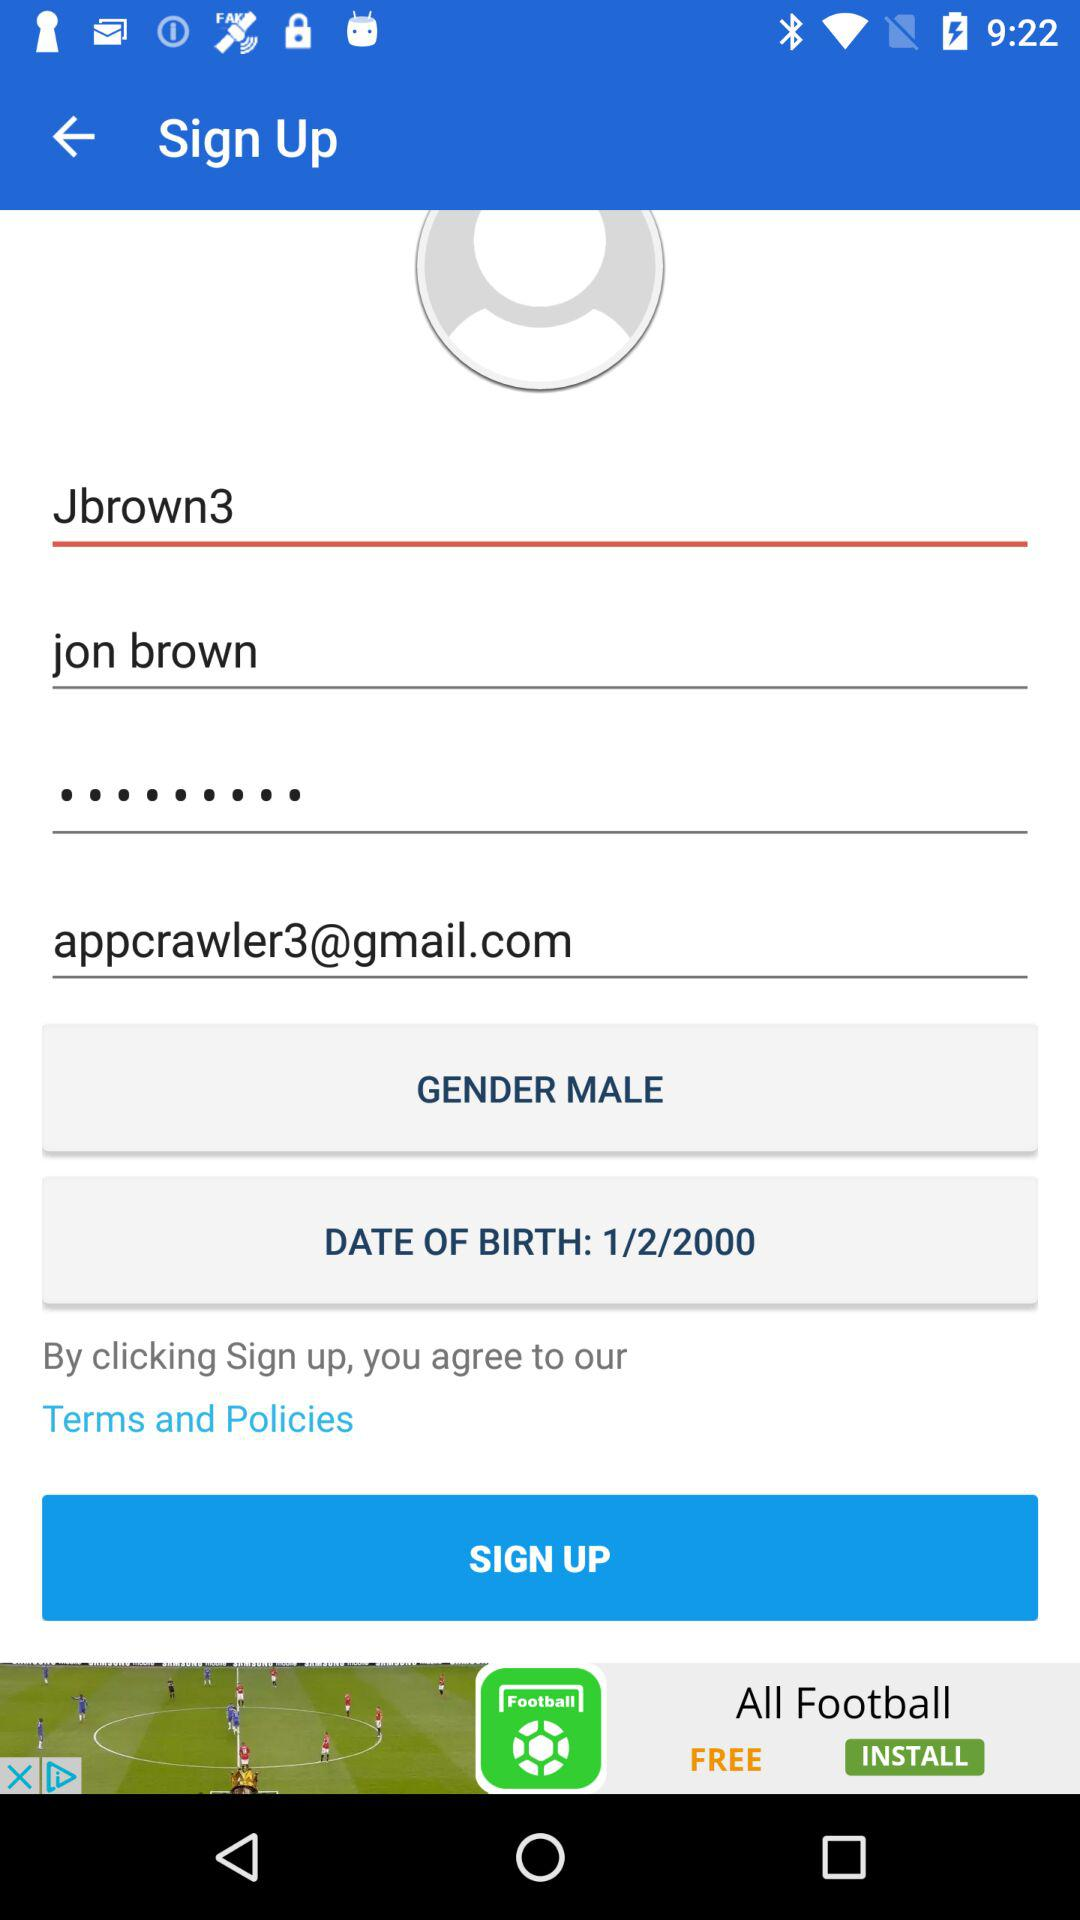What is the login name? The login name is Jon Brown. 